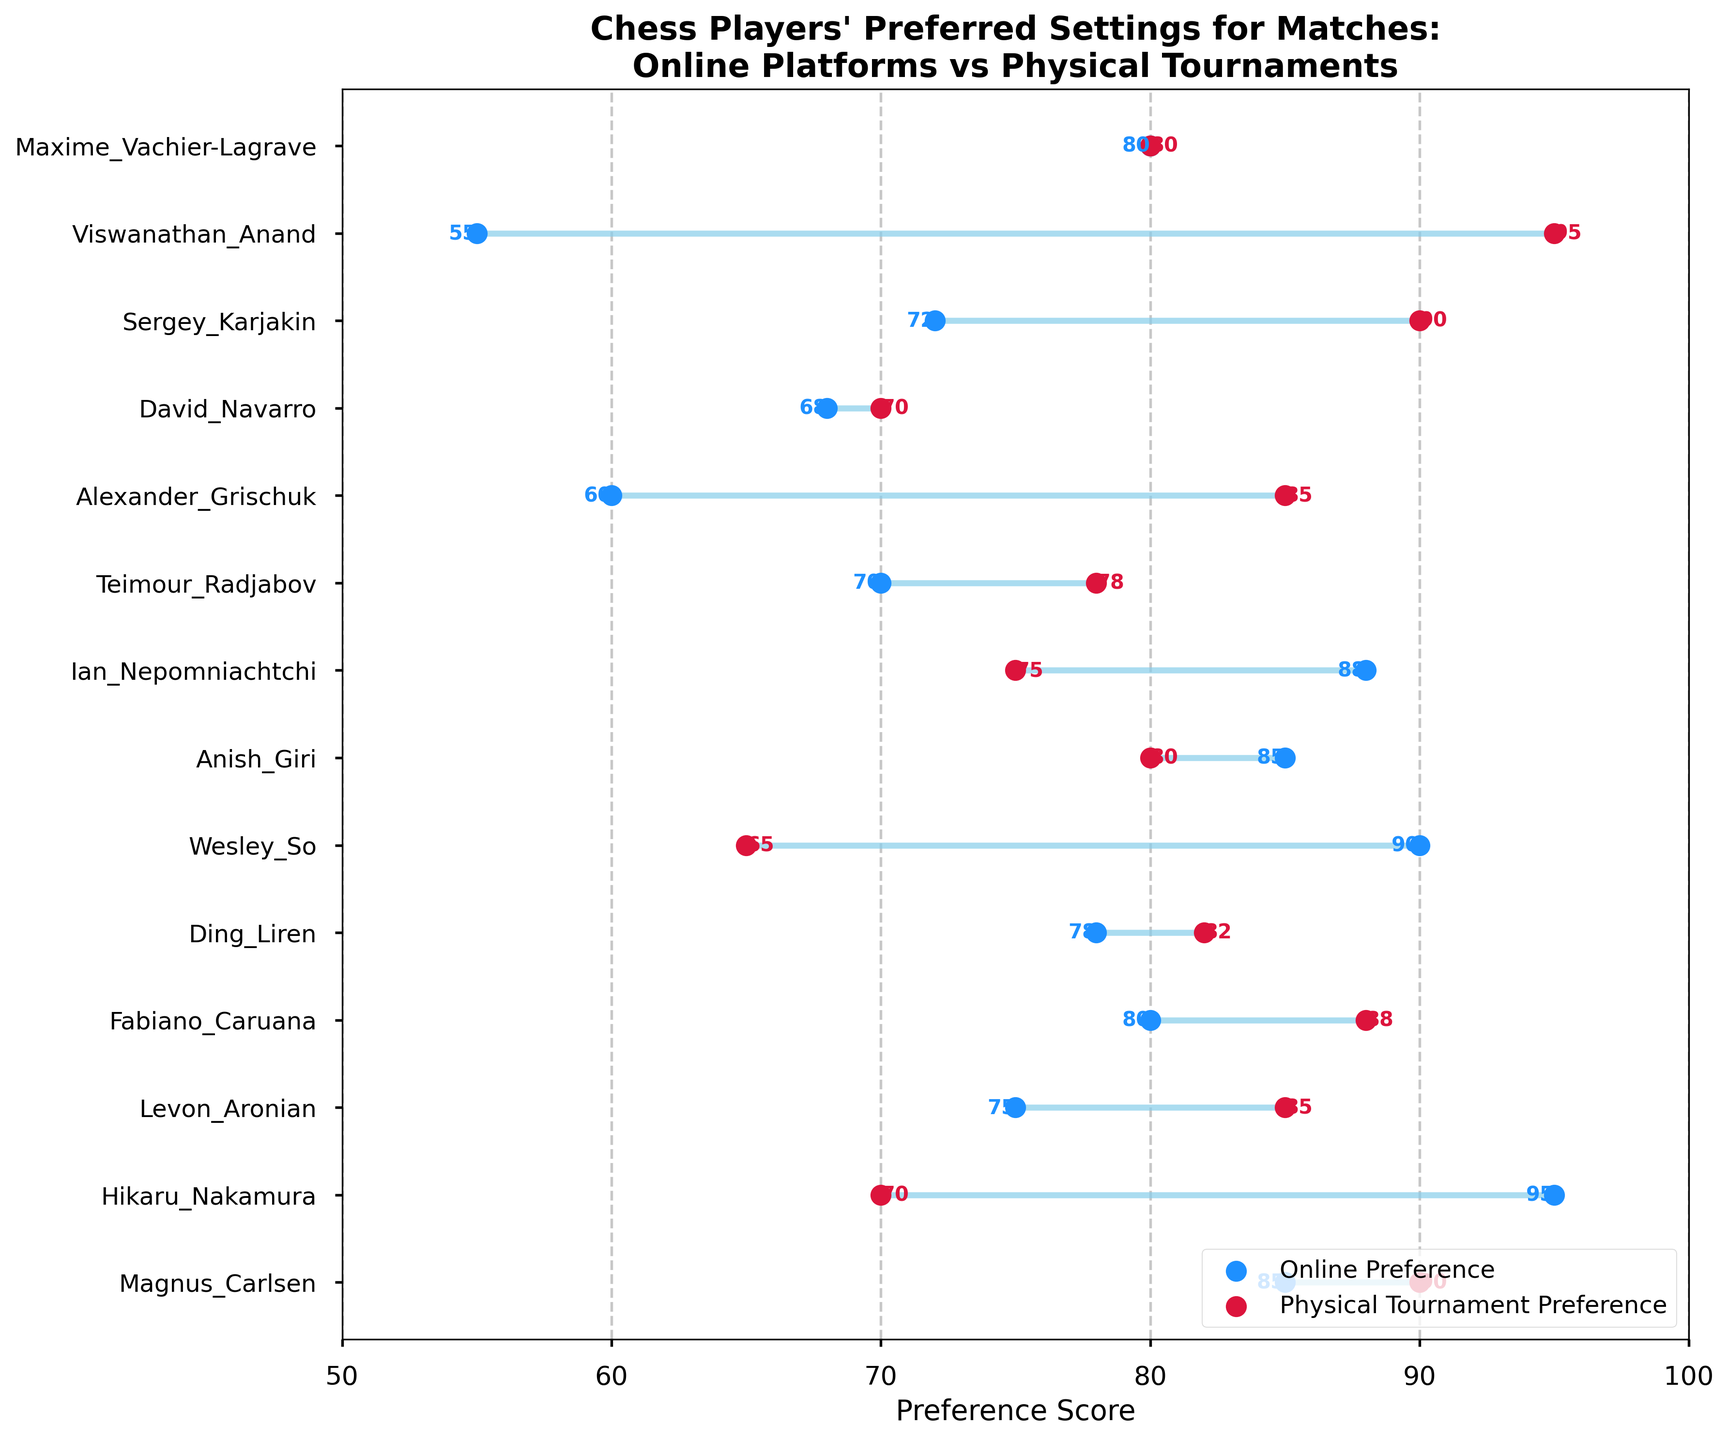What's the title of the plot? The title is prominently displayed at the top of the figure, summarizing the information shown in the plot, indicating the main topic.
Answer: Chess Players' Preferred Settings for Matches: Online Platforms vs Physical Tournaments Which player has the highest online preference score? To find the player with the highest online preference score, we look for the maximum value in the 'Online Preference' column and identify the corresponding player.
Answer: Hikaru Nakamura What is the average physical tournament preference score of all players? Add all the physical tournament preference scores and divide by the number of players. Calculation: (90 + 70 + 85 + 88 + 82 + 65 + 80 + 75 + 78 + 85 + 70 + 90 + 95 + 80) / 14 = 83
Answer: 83 Which player exhibits the greatest difference between their online and physical tournament preferences? Calculate the absolute differences between online and physical preferences for each player and identify the player with the largest value.
Answer: Wesley So Who prefers physical tournaments significantly more than online platforms? We look for players whose physical tournament preference score is significantly higher than their online preference score. The players with a notably higher preference for physical tournaments include Magnus_Carlsen (90 vs 85), Levon_Aronian (85 vs 75), Ding_Liren (82 vs 78), Alexander_Grischuk (85 vs 60), and Viswanathan_Anand (95 vs 55).
Answer: Viswanathan Anand How many players are there in total? Count the individual data points, which correspond to the number of unique players listed in the plot.
Answer: 14 What is Anish Giri's preference score for physical tournaments? Locate Anish Giri in the y-axis and refer to the value marked in red (for physical preferences).
Answer: 80 Between Ian Nepomniachtchi and Teimour Radjabov, who prefers online platforms more? Compare the online preference scores of both players. Ian Nepomniachtchi has an online score of 88, whereas Teimour Radjabov has an online score of 70.
Answer: Ian Nepomniachtchi What is the median online preference score? Arrange the online preference scores in ascending order and find the median value (the middle number for an odd count or the average of the two middle numbers for an even count).
Answer: 78.5 Which player's preference scores for online platforms and physical tournaments are exactly equal? Identify the player whose online and physical tournament preference scores are the same, which means they are marked by overlapping blue and red dots.
Answer: Maxime Vachier-Lagrave 